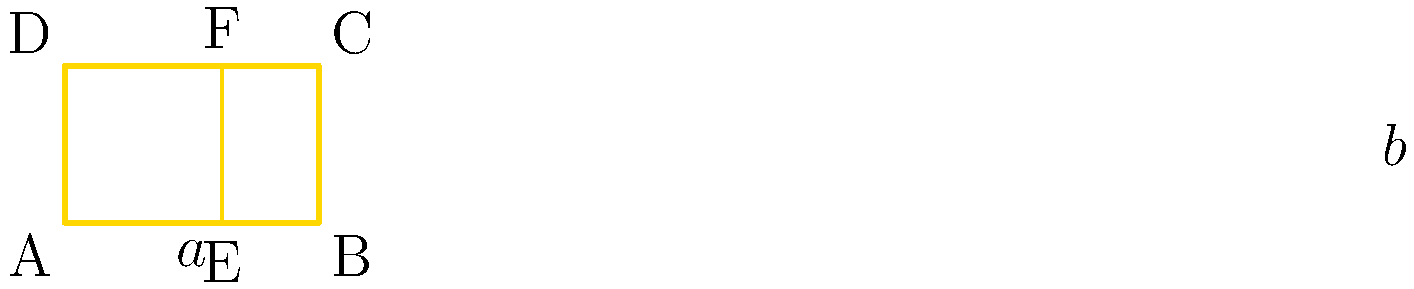In the golden rectangle ABCD, point E divides side AB in the golden ratio. If the shorter side of the rectangle is $a$ and the longer side is $a+b$, what is the ratio of $a$ to $b$ expressed as a decimal to two decimal places? Let's approach this step-by-step:

1) The golden ratio is defined as $(a+b):a = a:b$

2) This can be expressed mathematically as:
   $\frac{a+b}{a} = \frac{a}{b}$

3) Let's call this ratio $\phi$. So, $\phi = \frac{a+b}{a} = \frac{a}{b}$

4) From the second part of this equation, we can say:
   $a = \phi b$

5) Substituting this into the first part of the equation:
   $\phi = \frac{\phi b + b}{\phi b} = 1 + \frac{1}{\phi}$

6) Multiply both sides by $\phi$:
   $\phi^2 = \phi + 1$

7) Rearrange to standard quadratic form:
   $\phi^2 - \phi - 1 = 0$

8) Use the quadratic formula to solve:
   $\phi = \frac{1 + \sqrt{5}}{2} \approx 1.618$

9) Now, we need to find $\frac{a}{b}$. Remember, $\frac{a}{b} = \phi$

10) Therefore, $\frac{a}{b} \approx 1.618$

11) Rounding to two decimal places: $\frac{a}{b} \approx 1.62$
Answer: 1.62 